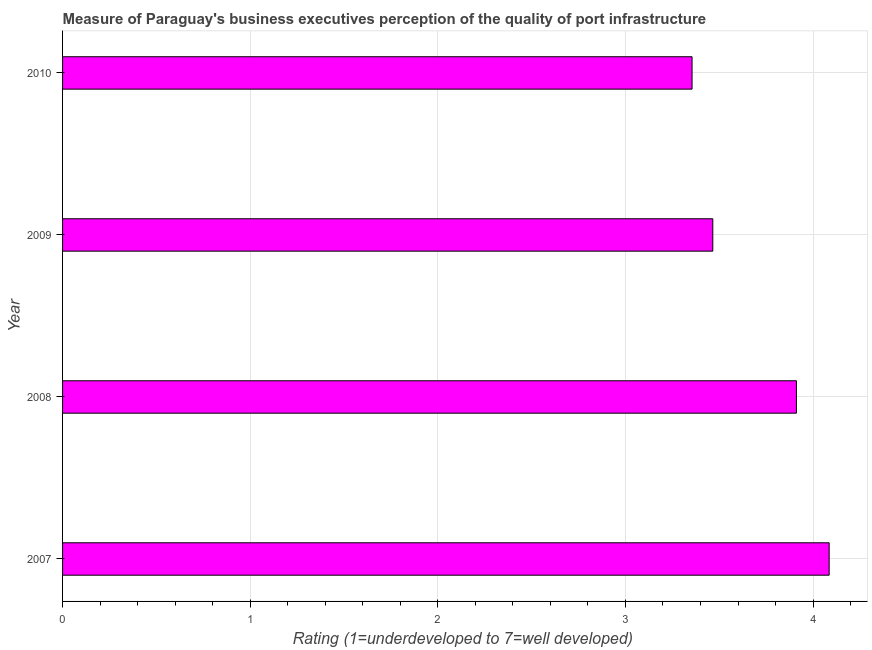Does the graph contain grids?
Offer a terse response. Yes. What is the title of the graph?
Offer a terse response. Measure of Paraguay's business executives perception of the quality of port infrastructure. What is the label or title of the X-axis?
Your response must be concise. Rating (1=underdeveloped to 7=well developed) . What is the label or title of the Y-axis?
Give a very brief answer. Year. What is the rating measuring quality of port infrastructure in 2008?
Your response must be concise. 3.91. Across all years, what is the maximum rating measuring quality of port infrastructure?
Keep it short and to the point. 4.09. Across all years, what is the minimum rating measuring quality of port infrastructure?
Your answer should be compact. 3.35. In which year was the rating measuring quality of port infrastructure maximum?
Offer a terse response. 2007. What is the sum of the rating measuring quality of port infrastructure?
Make the answer very short. 14.82. What is the difference between the rating measuring quality of port infrastructure in 2007 and 2010?
Offer a very short reply. 0.73. What is the average rating measuring quality of port infrastructure per year?
Your response must be concise. 3.7. What is the median rating measuring quality of port infrastructure?
Make the answer very short. 3.69. Do a majority of the years between 2008 and 2009 (inclusive) have rating measuring quality of port infrastructure greater than 3 ?
Provide a short and direct response. Yes. What is the ratio of the rating measuring quality of port infrastructure in 2009 to that in 2010?
Keep it short and to the point. 1.03. Is the rating measuring quality of port infrastructure in 2007 less than that in 2008?
Provide a short and direct response. No. Is the difference between the rating measuring quality of port infrastructure in 2008 and 2009 greater than the difference between any two years?
Offer a very short reply. No. What is the difference between the highest and the second highest rating measuring quality of port infrastructure?
Offer a very short reply. 0.17. What is the difference between the highest and the lowest rating measuring quality of port infrastructure?
Give a very brief answer. 0.73. How many years are there in the graph?
Your answer should be very brief. 4. What is the difference between two consecutive major ticks on the X-axis?
Give a very brief answer. 1. Are the values on the major ticks of X-axis written in scientific E-notation?
Offer a very short reply. No. What is the Rating (1=underdeveloped to 7=well developed)  of 2007?
Make the answer very short. 4.09. What is the Rating (1=underdeveloped to 7=well developed)  of 2008?
Offer a very short reply. 3.91. What is the Rating (1=underdeveloped to 7=well developed)  of 2009?
Keep it short and to the point. 3.47. What is the Rating (1=underdeveloped to 7=well developed)  in 2010?
Your answer should be very brief. 3.35. What is the difference between the Rating (1=underdeveloped to 7=well developed)  in 2007 and 2008?
Keep it short and to the point. 0.17. What is the difference between the Rating (1=underdeveloped to 7=well developed)  in 2007 and 2009?
Your answer should be very brief. 0.62. What is the difference between the Rating (1=underdeveloped to 7=well developed)  in 2007 and 2010?
Your response must be concise. 0.73. What is the difference between the Rating (1=underdeveloped to 7=well developed)  in 2008 and 2009?
Provide a short and direct response. 0.45. What is the difference between the Rating (1=underdeveloped to 7=well developed)  in 2008 and 2010?
Provide a short and direct response. 0.56. What is the difference between the Rating (1=underdeveloped to 7=well developed)  in 2009 and 2010?
Provide a succinct answer. 0.11. What is the ratio of the Rating (1=underdeveloped to 7=well developed)  in 2007 to that in 2008?
Your answer should be compact. 1.04. What is the ratio of the Rating (1=underdeveloped to 7=well developed)  in 2007 to that in 2009?
Your response must be concise. 1.18. What is the ratio of the Rating (1=underdeveloped to 7=well developed)  in 2007 to that in 2010?
Provide a succinct answer. 1.22. What is the ratio of the Rating (1=underdeveloped to 7=well developed)  in 2008 to that in 2009?
Give a very brief answer. 1.13. What is the ratio of the Rating (1=underdeveloped to 7=well developed)  in 2008 to that in 2010?
Offer a terse response. 1.17. What is the ratio of the Rating (1=underdeveloped to 7=well developed)  in 2009 to that in 2010?
Provide a short and direct response. 1.03. 